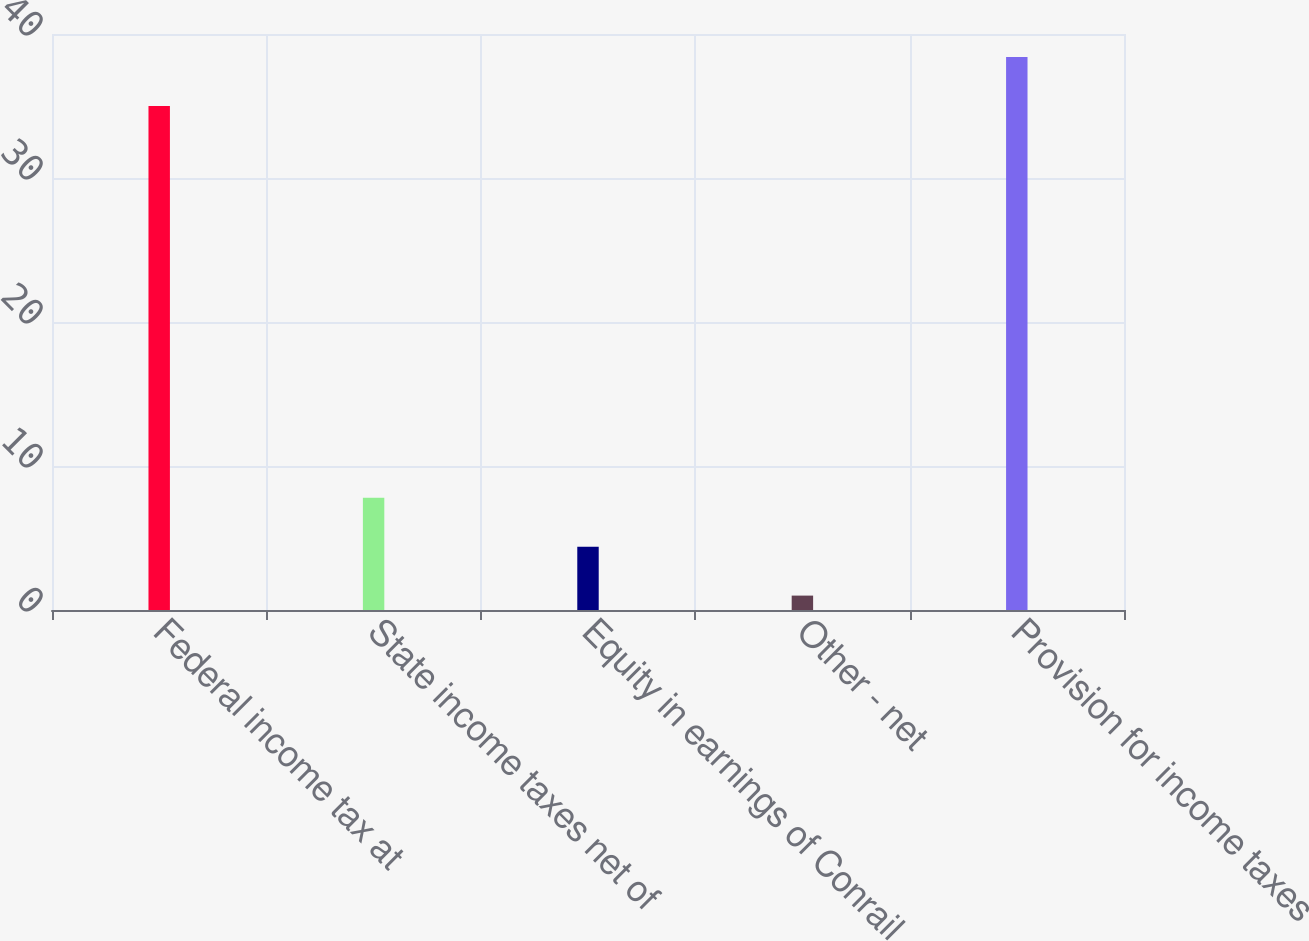<chart> <loc_0><loc_0><loc_500><loc_500><bar_chart><fcel>Federal income tax at<fcel>State income taxes net of<fcel>Equity in earnings of Conrail<fcel>Other - net<fcel>Provision for income taxes<nl><fcel>35<fcel>7.8<fcel>4.4<fcel>1<fcel>38.4<nl></chart> 